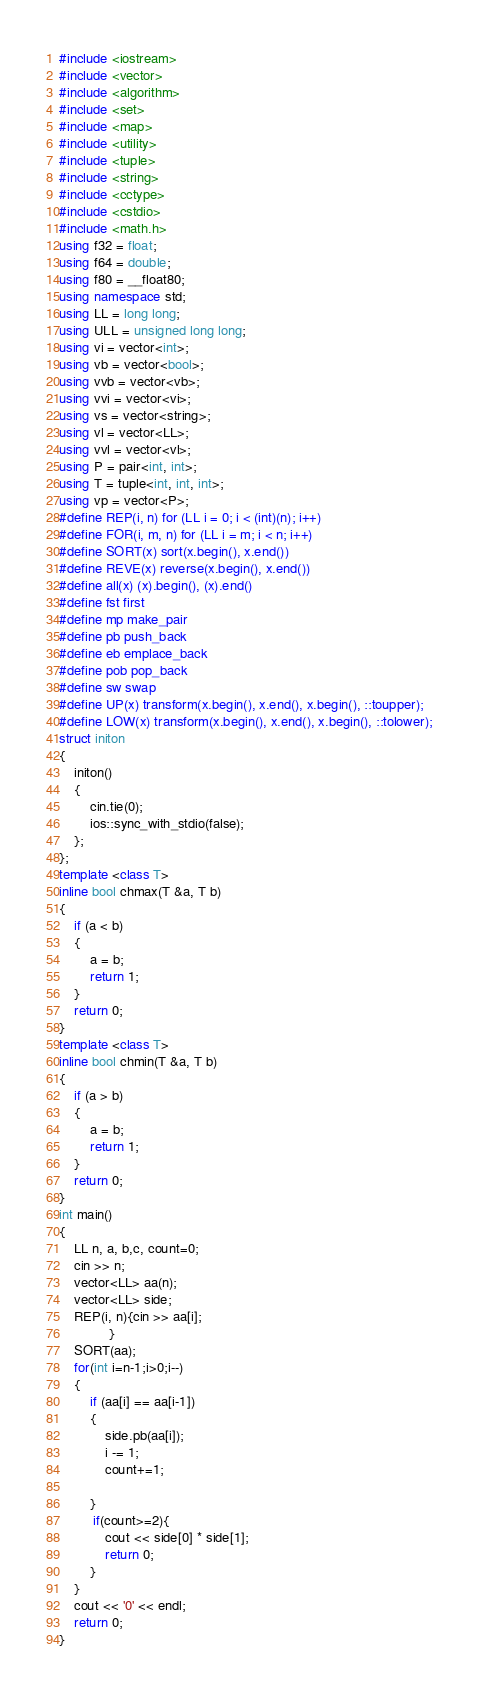Convert code to text. <code><loc_0><loc_0><loc_500><loc_500><_C++_>#include <iostream>
#include <vector>
#include <algorithm>
#include <set>
#include <map>
#include <utility>
#include <tuple>
#include <string>
#include <cctype>
#include <cstdio>
#include <math.h>
using f32 = float;
using f64 = double;
using f80 = __float80;
using namespace std;
using LL = long long;
using ULL = unsigned long long;
using vi = vector<int>;
using vb = vector<bool>;
using vvb = vector<vb>;
using vvi = vector<vi>;
using vs = vector<string>;
using vl = vector<LL>;
using vvl = vector<vl>;
using P = pair<int, int>;
using T = tuple<int, int, int>;
using vp = vector<P>;
#define REP(i, n) for (LL i = 0; i < (int)(n); i++)
#define FOR(i, m, n) for (LL i = m; i < n; i++)
#define SORT(x) sort(x.begin(), x.end())
#define REVE(x) reverse(x.begin(), x.end())
#define all(x) (x).begin(), (x).end()
#define fst first
#define mp make_pair
#define pb push_back
#define eb emplace_back
#define pob pop_back
#define sw swap
#define UP(x) transform(x.begin(), x.end(), x.begin(), ::toupper);
#define LOW(x) transform(x.begin(), x.end(), x.begin(), ::tolower);
struct initon
{
    initon()
    {
        cin.tie(0);
        ios::sync_with_stdio(false);
    };
};
template <class T>
inline bool chmax(T &a, T b)
{
    if (a < b)
    {
        a = b;
        return 1;
    }
    return 0;
}
template <class T>
inline bool chmin(T &a, T b)
{
    if (a > b)
    {
        a = b;
        return 1;
    }
    return 0;
}
int main()
{
    LL n, a, b,c, count=0;
    cin >> n;
    vector<LL> aa(n);
    vector<LL> side;
    REP(i, n){cin >> aa[i];
             }
    SORT(aa);
    for(int i=n-1;i>0;i--)
    {
        if (aa[i] == aa[i-1])
        {
            side.pb(aa[i]);
            i -= 1;
            count+=1;

        }
         if(count>=2){
            cout << side[0] * side[1];
            return 0;
        }
    }
    cout << '0' << endl;
    return 0;
}</code> 